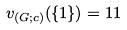Convert formula to latex. <formula><loc_0><loc_0><loc_500><loc_500>v _ { ( G ; c ) } ( \{ 1 \} ) = 1 1</formula> 